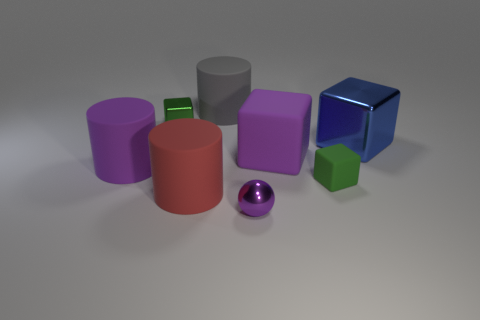Subtract all yellow blocks. Subtract all blue cylinders. How many blocks are left? 4 Add 1 purple cylinders. How many objects exist? 9 Subtract all cylinders. How many objects are left? 5 Add 4 rubber things. How many rubber things are left? 9 Add 6 red things. How many red things exist? 7 Subtract 0 brown cylinders. How many objects are left? 8 Subtract all small purple things. Subtract all small purple shiny balls. How many objects are left? 6 